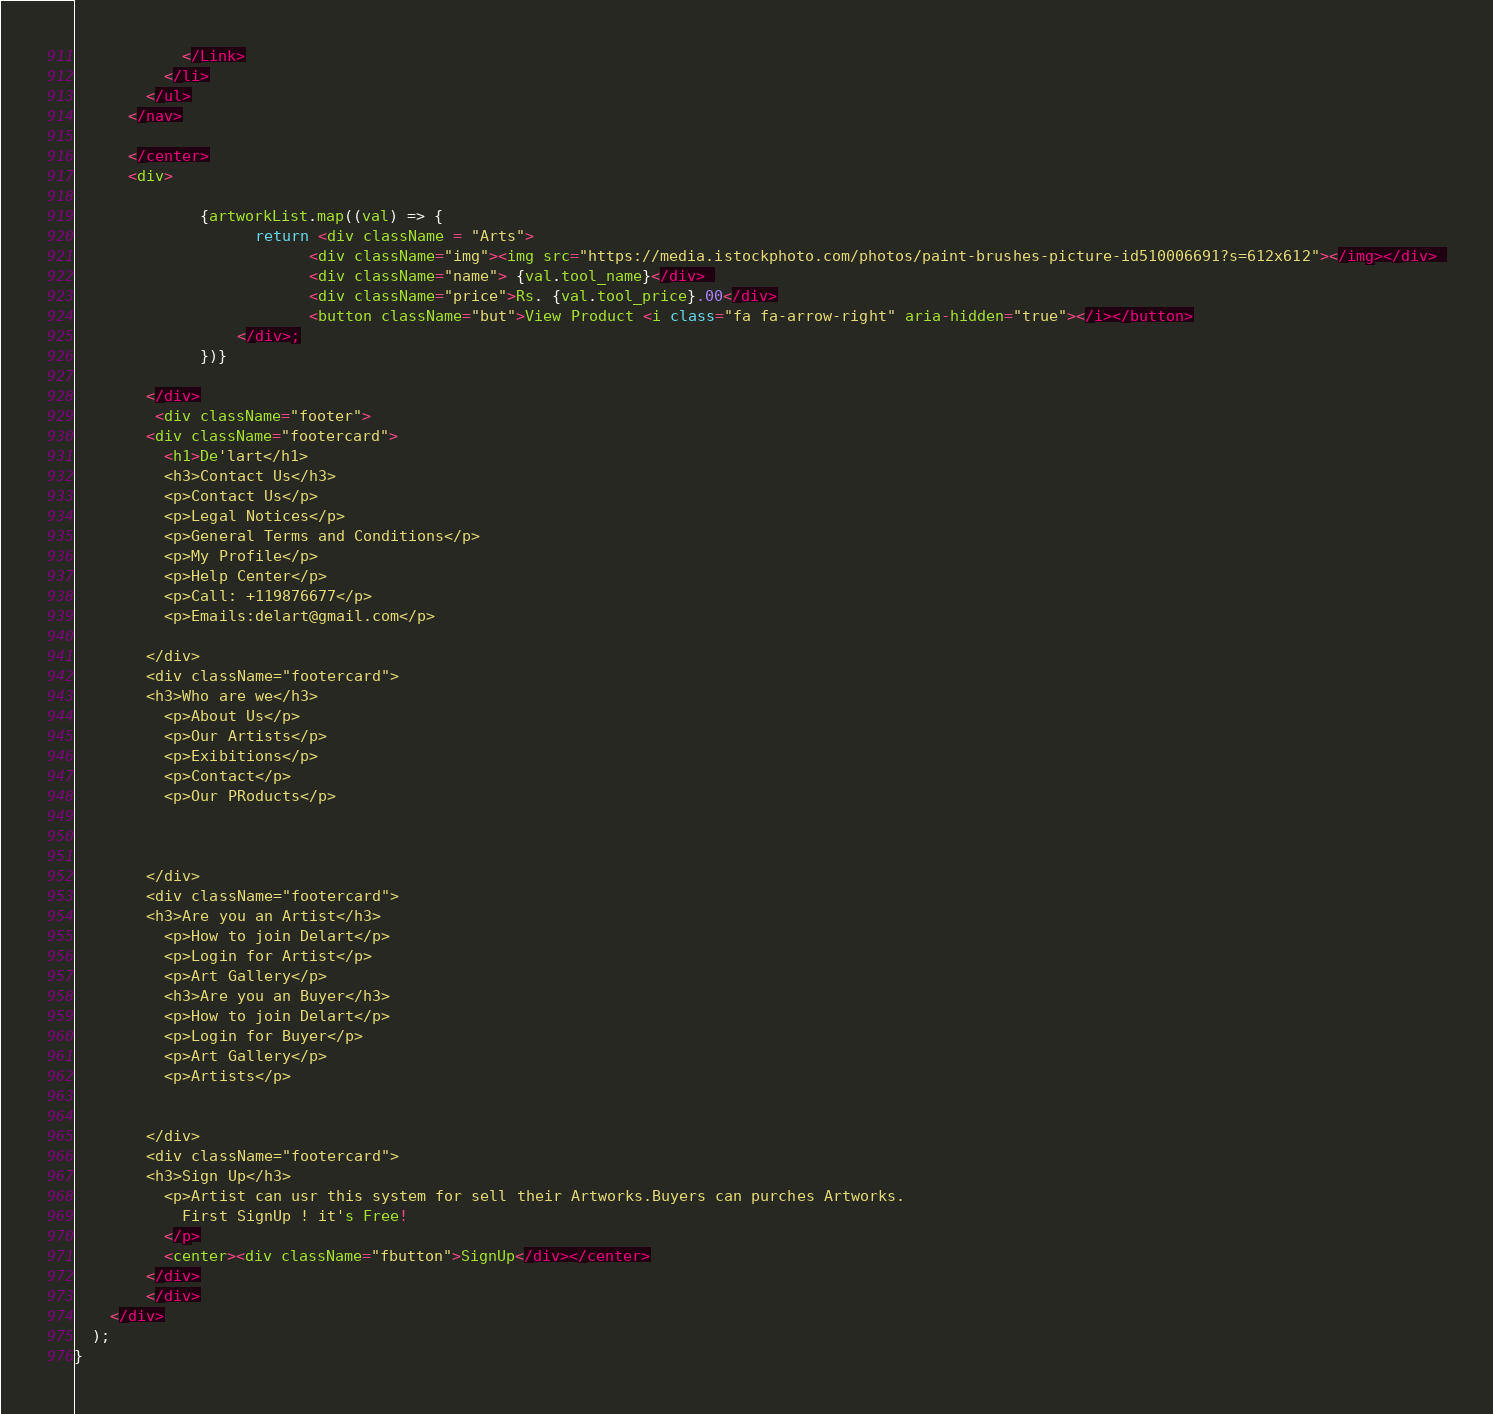Convert code to text. <code><loc_0><loc_0><loc_500><loc_500><_JavaScript_>            </Link>
          </li>
        </ul>
      </nav>
  
      </center>
      <div>
              
              {artworkList.map((val) => {
                    return <div className = "Arts"> 
                          <div className="img"><img src="https://media.istockphoto.com/photos/paint-brushes-picture-id510006691?s=612x612"></img></div> 
                          <div className="name"> {val.tool_name}</div> 
                          <div className="price">Rs. {val.tool_price}.00</div>
                          <button className="but">View Product <i class="fa fa-arrow-right" aria-hidden="true"></i></button>
                  </div>;
              })}
              
        </div>
         <div className="footer">
        <div className="footercard">
          <h1>De'lart</h1>
          <h3>Contact Us</h3>
          <p>Contact Us</p>
          <p>Legal Notices</p>
          <p>General Terms and Conditions</p>
          <p>My Profile</p>
          <p>Help Center</p>
          <p>Call: +119876677</p>
          <p>Emails:delart@gmail.com</p>
          
        </div>
        <div className="footercard">
        <h3>Who are we</h3>
          <p>About Us</p>
          <p>Our Artists</p>
          <p>Exibitions</p>
          <p>Contact</p>
          <p>Our PRoducts</p>
         
         
        
        </div>
        <div className="footercard">
        <h3>Are you an Artist</h3>
          <p>How to join Delart</p>
          <p>Login for Artist</p>
          <p>Art Gallery</p>
          <h3>Are you an Buyer</h3>
          <p>How to join Delart</p>
          <p>Login for Buyer</p>
          <p>Art Gallery</p>
          <p>Artists</p>
         
         
        </div>
        <div className="footercard">
        <h3>Sign Up</h3>
          <p>Artist can usr this system for sell their Artworks.Buyers can purches Artworks.
            First SignUp ! it's Free!
          </p>
          <center><div className="fbutton">SignUp</div></center>
        </div>
        </div>
    </div>
  );
}

</code> 